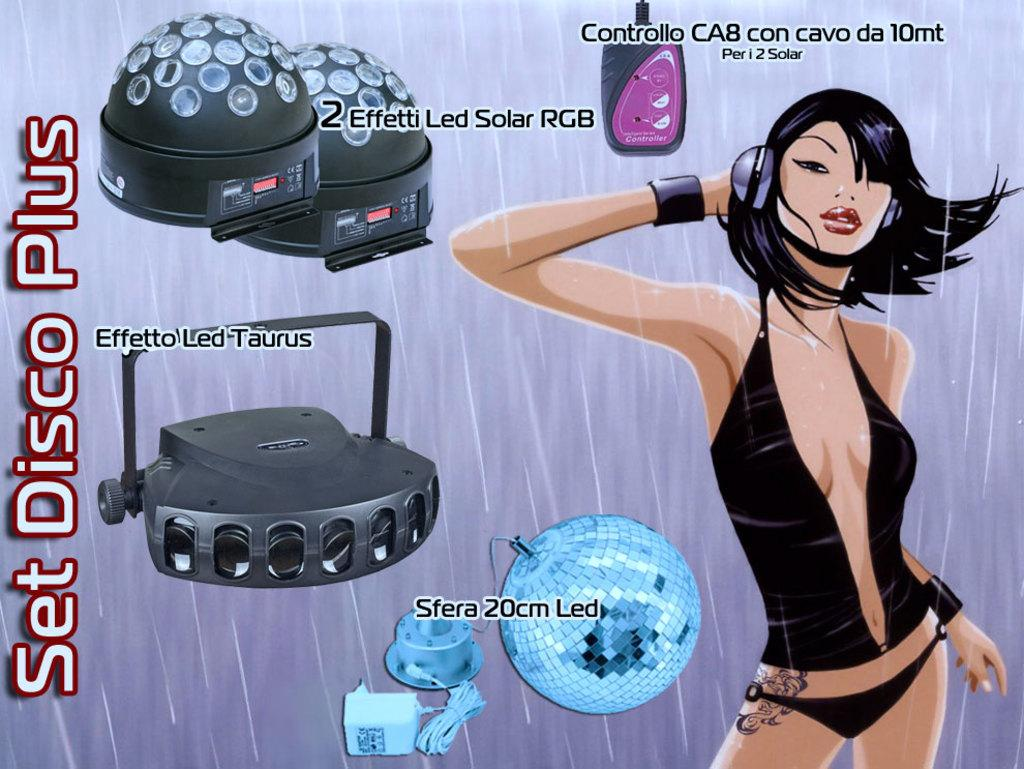What type of image is being described? The image is animated. Can you describe the characters or subjects in the image? There is a lady in the image. What additional elements can be seen in the image? Disco lights are present in the image. Is there any text or writing in the image? Yes, there is text in the image. What type of vegetable is being sold in the image? There is no vegetable being sold in the image; it features an animated lady and disco lights. Can you tell me the price of the wire in the image? There is no wire present in the image, so it is not possible to determine its price. 